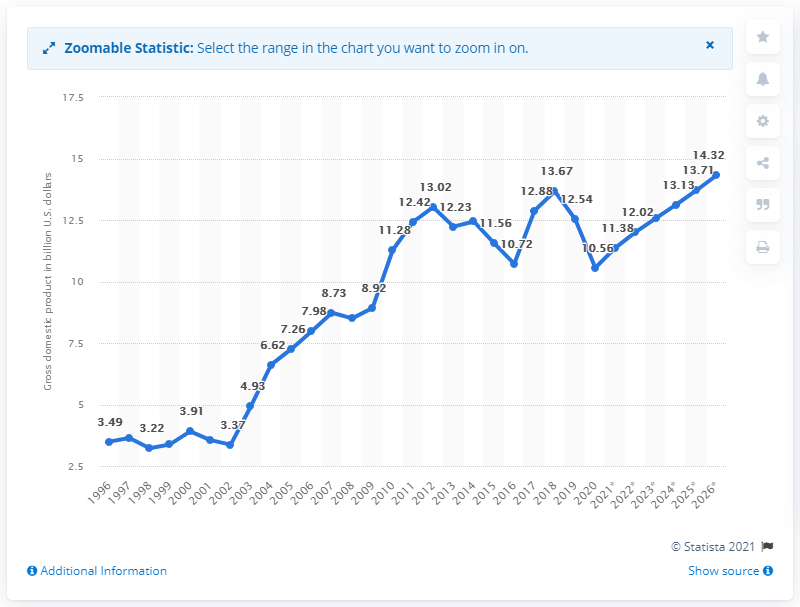Identify some key points in this picture. Namibia's Gross Domestic Product in dollars for the year 2020 was 10.56. 